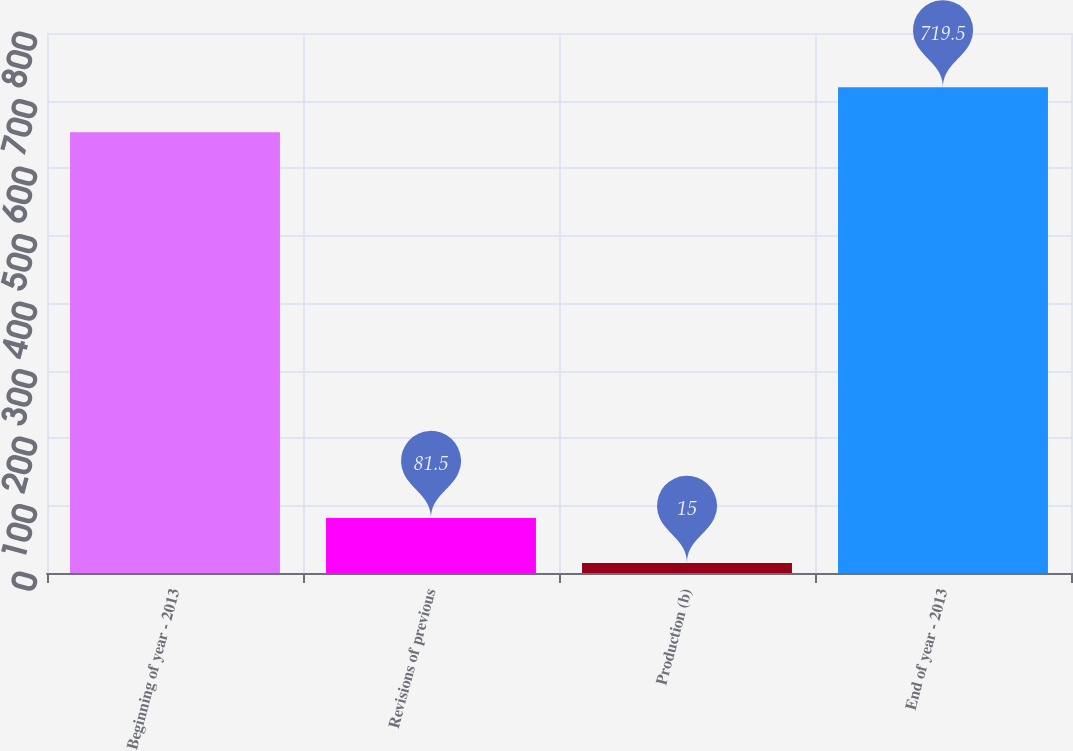Convert chart. <chart><loc_0><loc_0><loc_500><loc_500><bar_chart><fcel>Beginning of year - 2013<fcel>Revisions of previous<fcel>Production (b)<fcel>End of year - 2013<nl><fcel>653<fcel>81.5<fcel>15<fcel>719.5<nl></chart> 